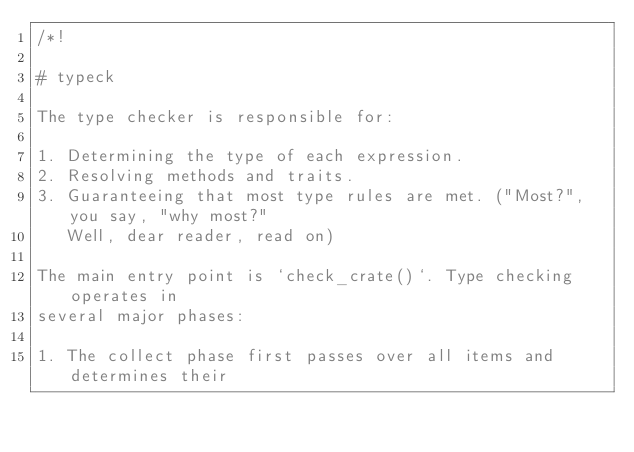Convert code to text. <code><loc_0><loc_0><loc_500><loc_500><_Rust_>/*!

# typeck

The type checker is responsible for:

1. Determining the type of each expression.
2. Resolving methods and traits.
3. Guaranteeing that most type rules are met. ("Most?", you say, "why most?"
   Well, dear reader, read on)

The main entry point is `check_crate()`. Type checking operates in
several major phases:

1. The collect phase first passes over all items and determines their</code> 